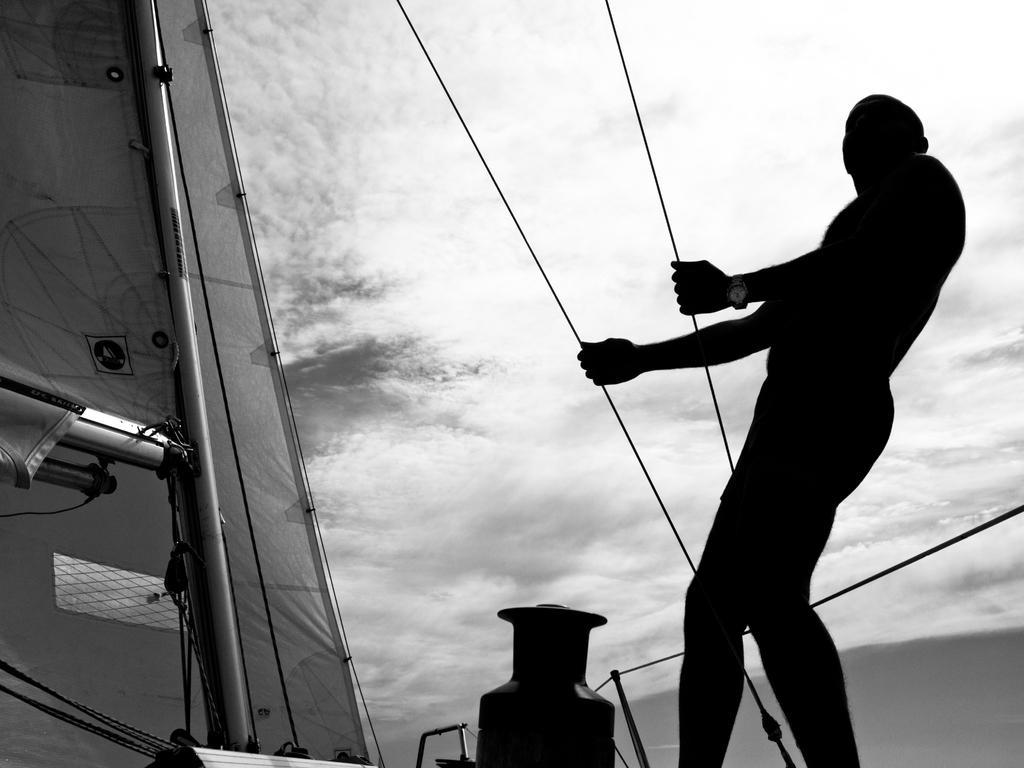Could you give a brief overview of what you see in this image? In this image a person is standing on the boat. He is holding the wires. Bottom of the image there is an object on the boat. Background there is sky with some clouds. 